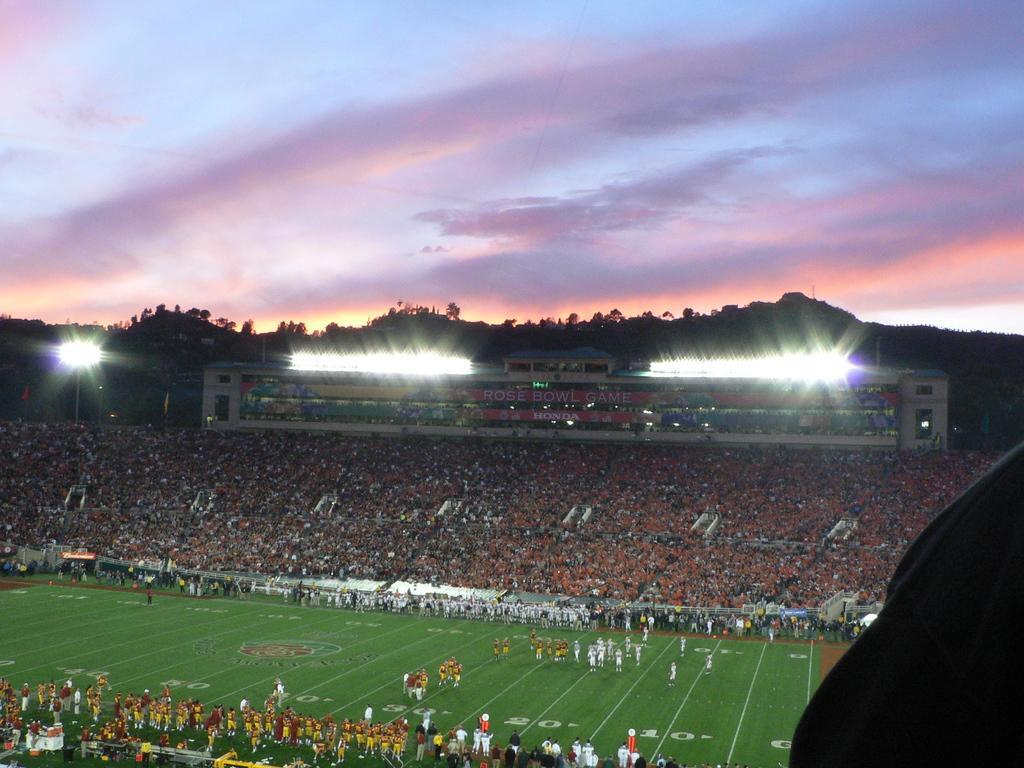How would you summarize this image in a sentence or two? In this image I can see the ground, number of persons standing on the ground and number of persons in the stadium. In the background I can see few lights, few trees, few mountains and the sky. 